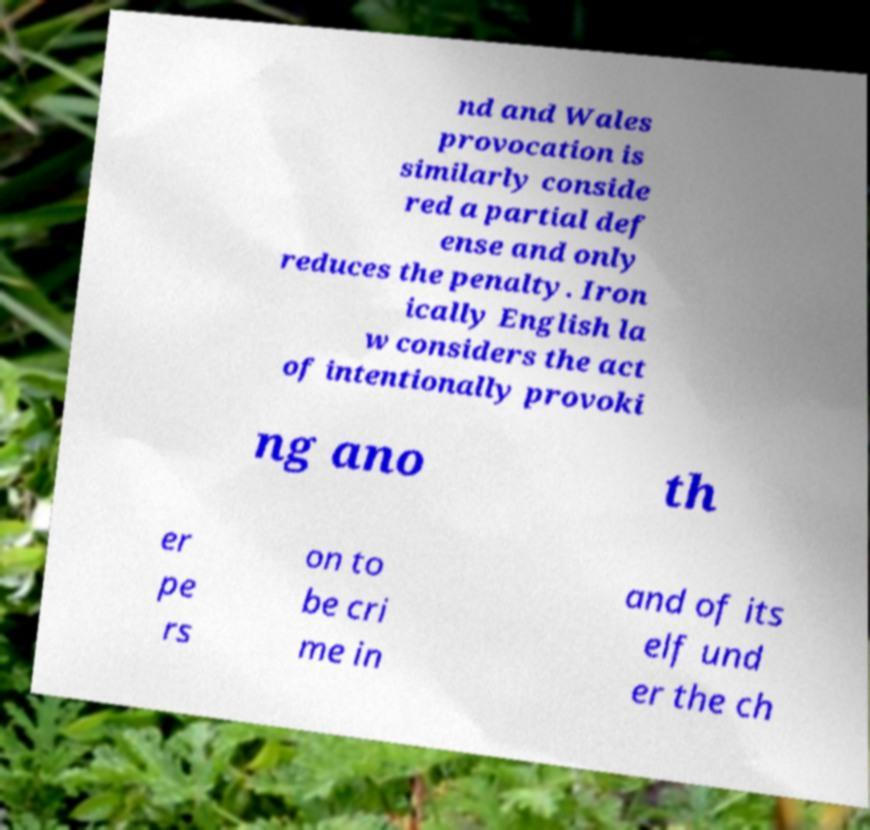Can you read and provide the text displayed in the image?This photo seems to have some interesting text. Can you extract and type it out for me? nd and Wales provocation is similarly conside red a partial def ense and only reduces the penalty. Iron ically English la w considers the act of intentionally provoki ng ano th er pe rs on to be cri me in and of its elf und er the ch 